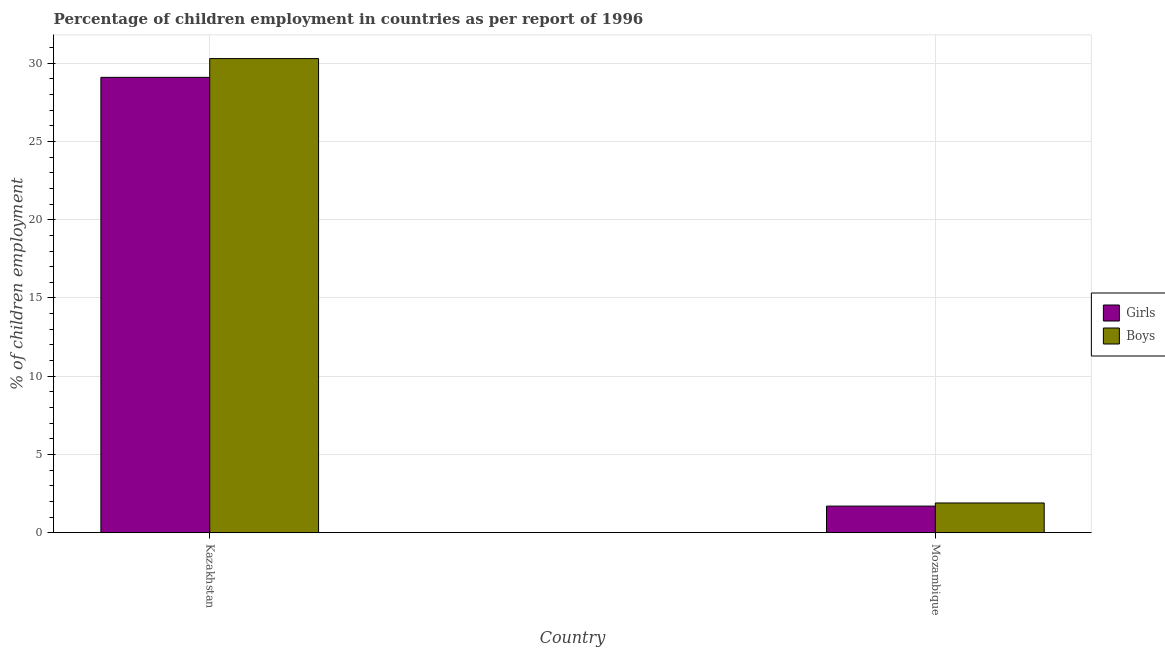How many different coloured bars are there?
Offer a very short reply. 2. How many groups of bars are there?
Offer a terse response. 2. Are the number of bars per tick equal to the number of legend labels?
Your answer should be very brief. Yes. What is the label of the 1st group of bars from the left?
Your response must be concise. Kazakhstan. Across all countries, what is the maximum percentage of employed boys?
Keep it short and to the point. 30.3. Across all countries, what is the minimum percentage of employed boys?
Keep it short and to the point. 1.9. In which country was the percentage of employed boys maximum?
Ensure brevity in your answer.  Kazakhstan. In which country was the percentage of employed boys minimum?
Offer a terse response. Mozambique. What is the total percentage of employed boys in the graph?
Give a very brief answer. 32.2. What is the difference between the percentage of employed girls in Kazakhstan and that in Mozambique?
Offer a very short reply. 27.4. What is the difference between the percentage of employed girls in Kazakhstan and the percentage of employed boys in Mozambique?
Make the answer very short. 27.2. What is the difference between the percentage of employed boys and percentage of employed girls in Kazakhstan?
Keep it short and to the point. 1.2. What is the ratio of the percentage of employed boys in Kazakhstan to that in Mozambique?
Ensure brevity in your answer.  15.95. What does the 1st bar from the left in Mozambique represents?
Ensure brevity in your answer.  Girls. What does the 2nd bar from the right in Mozambique represents?
Keep it short and to the point. Girls. How many bars are there?
Your response must be concise. 4. Are all the bars in the graph horizontal?
Ensure brevity in your answer.  No. How many countries are there in the graph?
Your answer should be compact. 2. What is the difference between two consecutive major ticks on the Y-axis?
Provide a short and direct response. 5. Are the values on the major ticks of Y-axis written in scientific E-notation?
Make the answer very short. No. Does the graph contain any zero values?
Provide a succinct answer. No. Does the graph contain grids?
Make the answer very short. Yes. Where does the legend appear in the graph?
Offer a terse response. Center right. What is the title of the graph?
Make the answer very short. Percentage of children employment in countries as per report of 1996. Does "External balance on goods" appear as one of the legend labels in the graph?
Make the answer very short. No. What is the label or title of the Y-axis?
Provide a short and direct response. % of children employment. What is the % of children employment in Girls in Kazakhstan?
Give a very brief answer. 29.1. What is the % of children employment of Boys in Kazakhstan?
Ensure brevity in your answer.  30.3. Across all countries, what is the maximum % of children employment in Girls?
Offer a very short reply. 29.1. Across all countries, what is the maximum % of children employment in Boys?
Make the answer very short. 30.3. Across all countries, what is the minimum % of children employment in Girls?
Provide a short and direct response. 1.7. What is the total % of children employment in Girls in the graph?
Your answer should be compact. 30.8. What is the total % of children employment in Boys in the graph?
Make the answer very short. 32.2. What is the difference between the % of children employment in Girls in Kazakhstan and that in Mozambique?
Offer a terse response. 27.4. What is the difference between the % of children employment of Boys in Kazakhstan and that in Mozambique?
Your response must be concise. 28.4. What is the difference between the % of children employment in Girls in Kazakhstan and the % of children employment in Boys in Mozambique?
Your answer should be very brief. 27.2. What is the ratio of the % of children employment in Girls in Kazakhstan to that in Mozambique?
Make the answer very short. 17.12. What is the ratio of the % of children employment of Boys in Kazakhstan to that in Mozambique?
Your answer should be compact. 15.95. What is the difference between the highest and the second highest % of children employment of Girls?
Keep it short and to the point. 27.4. What is the difference between the highest and the second highest % of children employment in Boys?
Your response must be concise. 28.4. What is the difference between the highest and the lowest % of children employment in Girls?
Your answer should be compact. 27.4. What is the difference between the highest and the lowest % of children employment of Boys?
Offer a terse response. 28.4. 